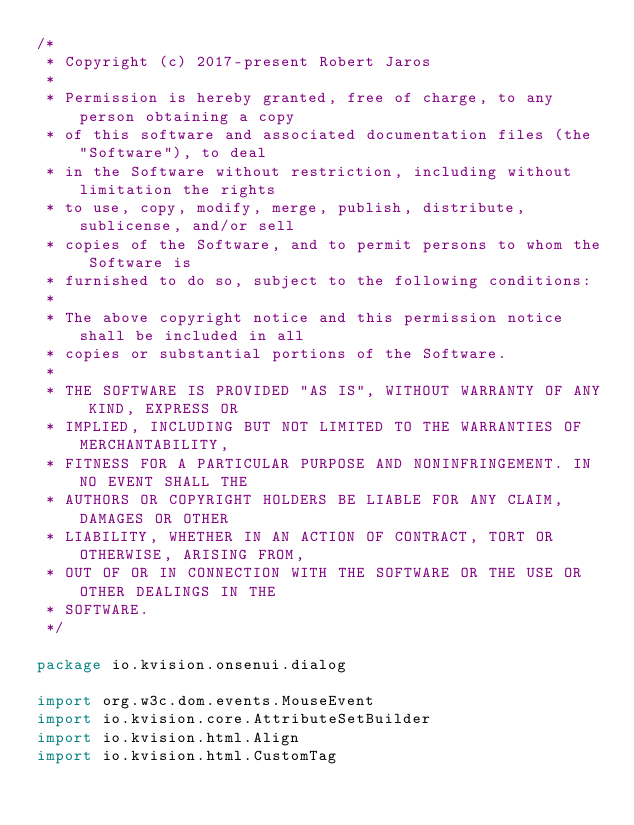Convert code to text. <code><loc_0><loc_0><loc_500><loc_500><_Kotlin_>/*
 * Copyright (c) 2017-present Robert Jaros
 *
 * Permission is hereby granted, free of charge, to any person obtaining a copy
 * of this software and associated documentation files (the "Software"), to deal
 * in the Software without restriction, including without limitation the rights
 * to use, copy, modify, merge, publish, distribute, sublicense, and/or sell
 * copies of the Software, and to permit persons to whom the Software is
 * furnished to do so, subject to the following conditions:
 *
 * The above copyright notice and this permission notice shall be included in all
 * copies or substantial portions of the Software.
 *
 * THE SOFTWARE IS PROVIDED "AS IS", WITHOUT WARRANTY OF ANY KIND, EXPRESS OR
 * IMPLIED, INCLUDING BUT NOT LIMITED TO THE WARRANTIES OF MERCHANTABILITY,
 * FITNESS FOR A PARTICULAR PURPOSE AND NONINFRINGEMENT. IN NO EVENT SHALL THE
 * AUTHORS OR COPYRIGHT HOLDERS BE LIABLE FOR ANY CLAIM, DAMAGES OR OTHER
 * LIABILITY, WHETHER IN AN ACTION OF CONTRACT, TORT OR OTHERWISE, ARISING FROM,
 * OUT OF OR IN CONNECTION WITH THE SOFTWARE OR THE USE OR OTHER DEALINGS IN THE
 * SOFTWARE.
 */

package io.kvision.onsenui.dialog

import org.w3c.dom.events.MouseEvent
import io.kvision.core.AttributeSetBuilder
import io.kvision.html.Align
import io.kvision.html.CustomTag</code> 